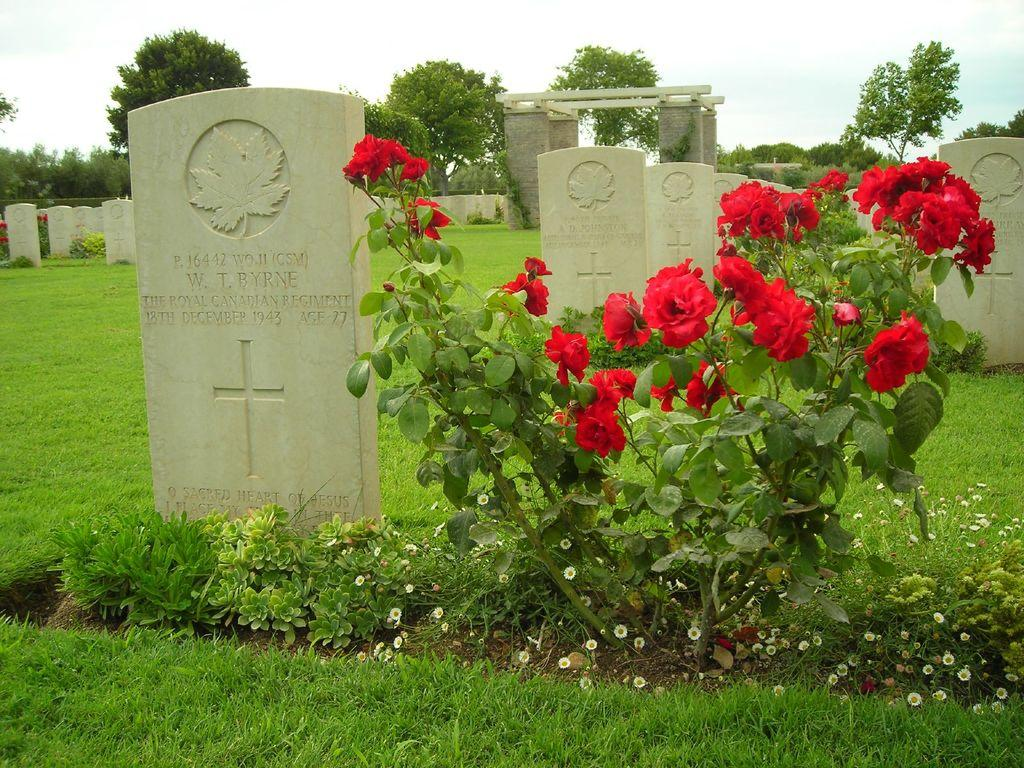What type of vegetation can be seen in the image? There are trees and plants with flowers in the image. What type of structures are present in the image? There are gravestones in the image. What is covering the ground in the image? Grass is present on the ground in the image. What is the condition of the sky in the image? The sky is cloudy in the image. How many rabbits can be seen playing with a ball in the image? There are no rabbits or balls present in the image. 